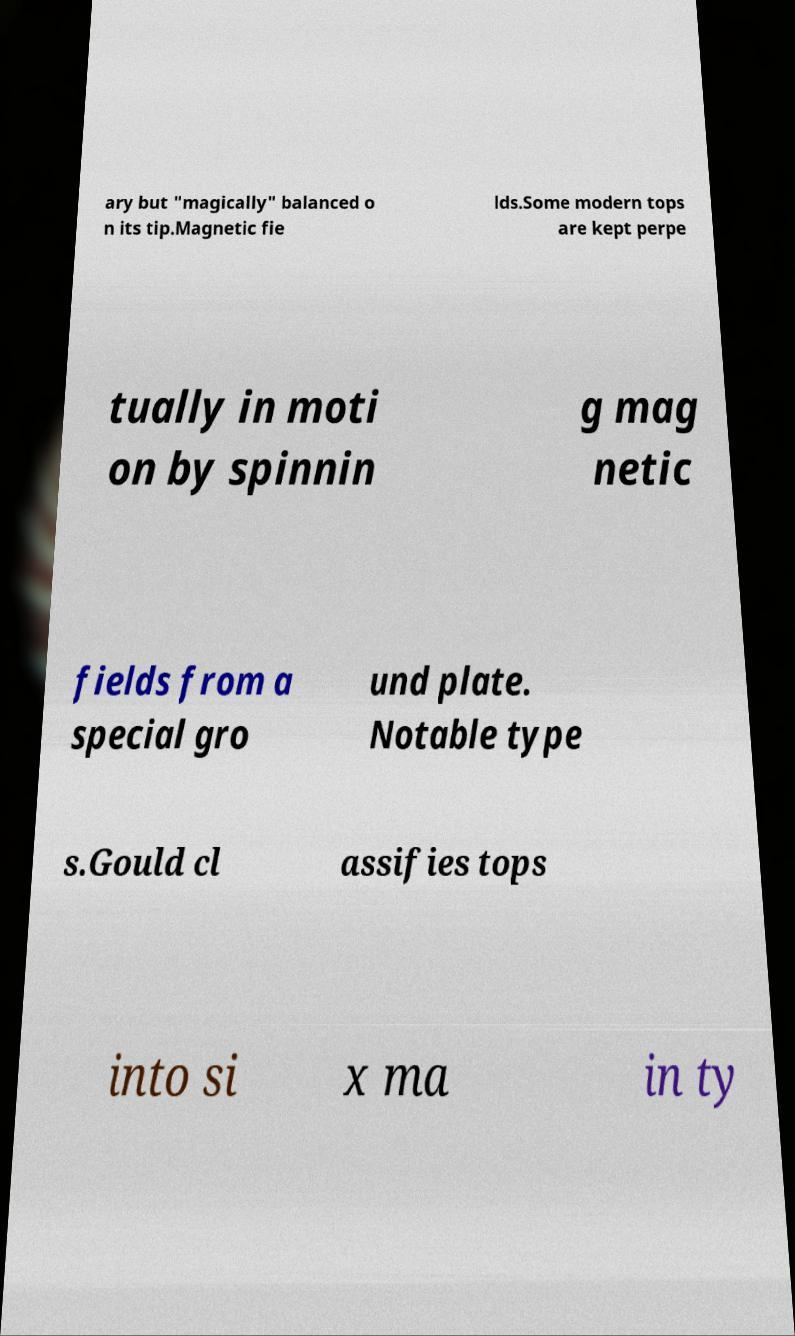Can you read and provide the text displayed in the image?This photo seems to have some interesting text. Can you extract and type it out for me? ary but "magically" balanced o n its tip.Magnetic fie lds.Some modern tops are kept perpe tually in moti on by spinnin g mag netic fields from a special gro und plate. Notable type s.Gould cl assifies tops into si x ma in ty 